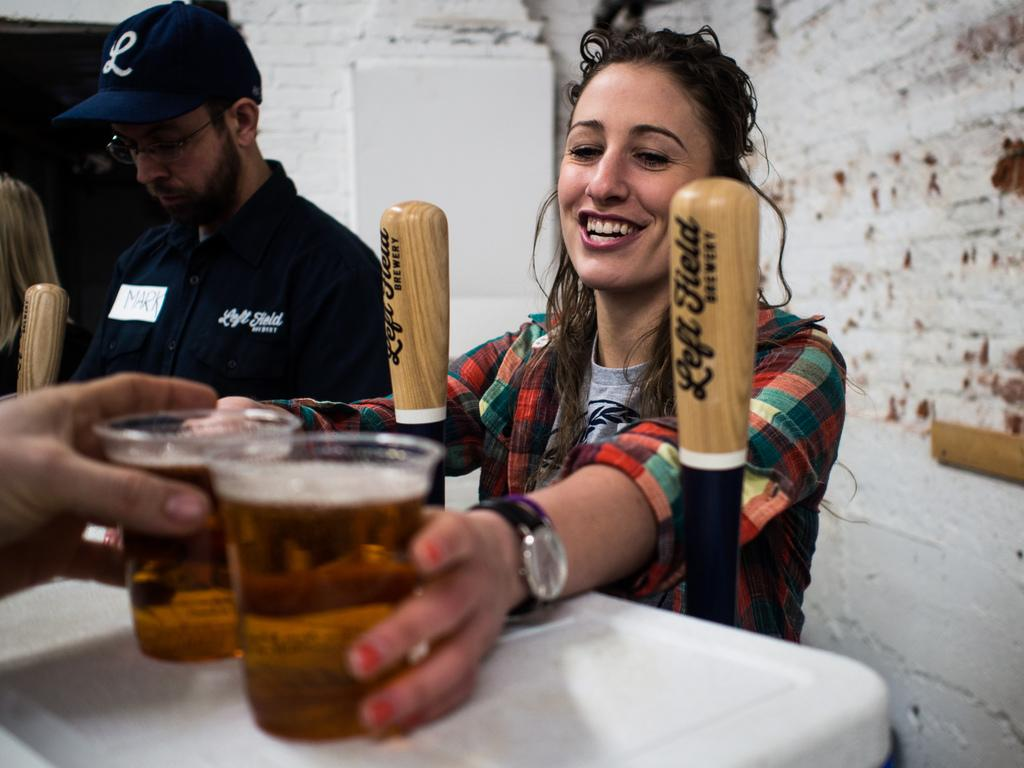How many people are in the image? There are three people in the image: two women and a man. What is the man wearing in the image? The man is wearing a cap in the image. What is one of the women holding in the image? One of the women is holding beer glasses in the image. What can be seen in the background of the image? There is a wall in the background of the image. What type of sweater is the secretary wearing in the image? There is no secretary present in the image, nor is there a sweater mentioned in the facts. 